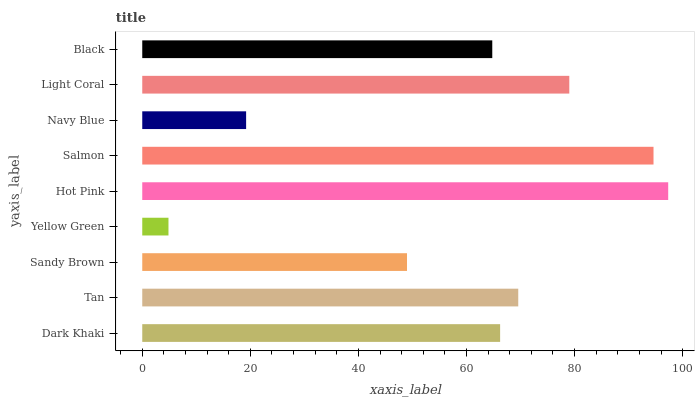Is Yellow Green the minimum?
Answer yes or no. Yes. Is Hot Pink the maximum?
Answer yes or no. Yes. Is Tan the minimum?
Answer yes or no. No. Is Tan the maximum?
Answer yes or no. No. Is Tan greater than Dark Khaki?
Answer yes or no. Yes. Is Dark Khaki less than Tan?
Answer yes or no. Yes. Is Dark Khaki greater than Tan?
Answer yes or no. No. Is Tan less than Dark Khaki?
Answer yes or no. No. Is Dark Khaki the high median?
Answer yes or no. Yes. Is Dark Khaki the low median?
Answer yes or no. Yes. Is Hot Pink the high median?
Answer yes or no. No. Is Black the low median?
Answer yes or no. No. 